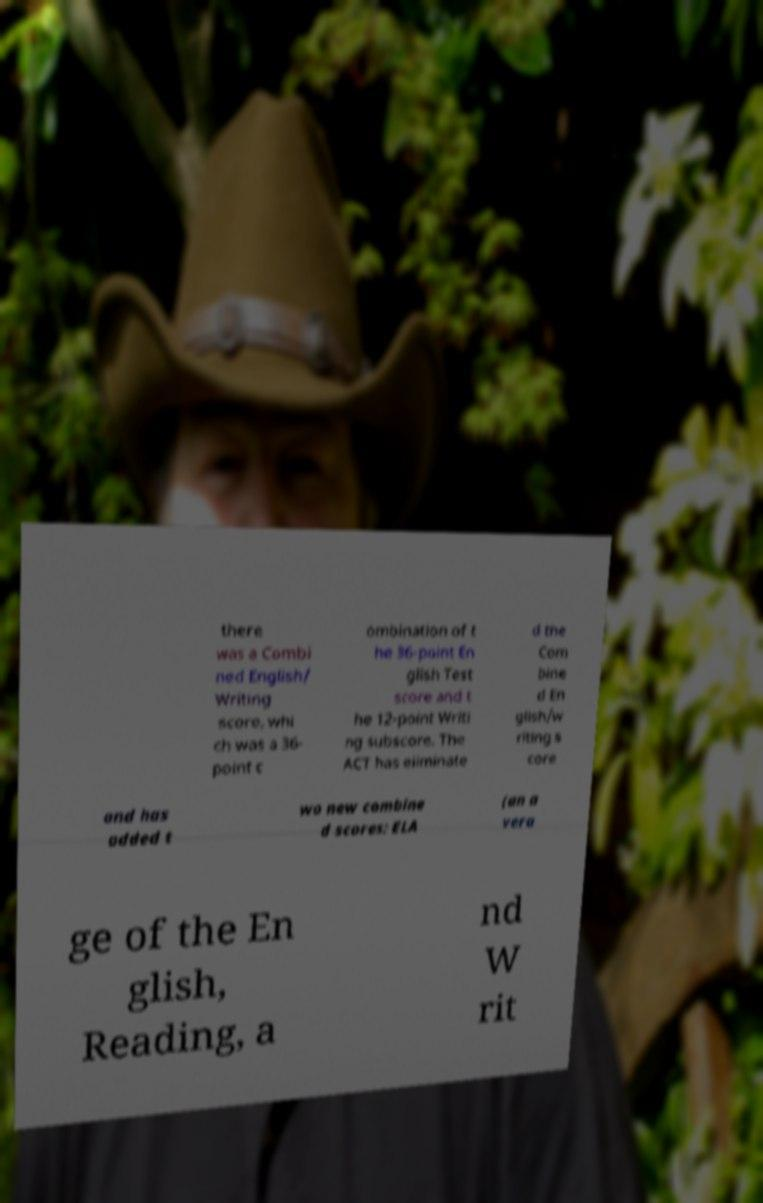I need the written content from this picture converted into text. Can you do that? there was a Combi ned English/ Writing score, whi ch was a 36- point c ombination of t he 36-point En glish Test score and t he 12-point Writi ng subscore. The ACT has eliminate d the Com bine d En glish/w riting s core and has added t wo new combine d scores: ELA (an a vera ge of the En glish, Reading, a nd W rit 